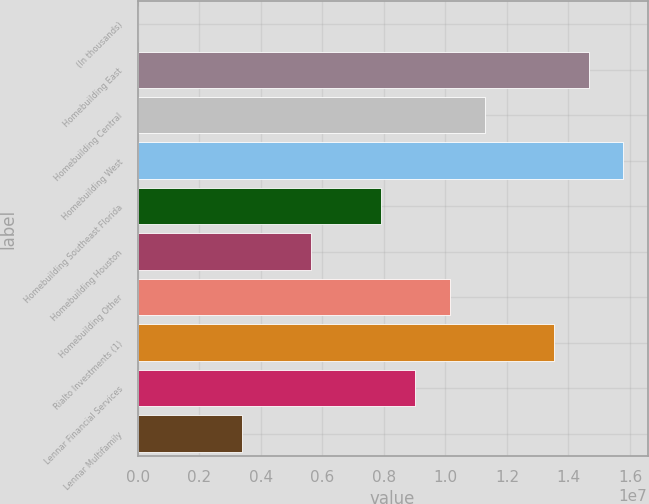Convert chart to OTSL. <chart><loc_0><loc_0><loc_500><loc_500><bar_chart><fcel>(In thousands)<fcel>Homebuilding East<fcel>Homebuilding Central<fcel>Homebuilding West<fcel>Homebuilding Southeast Florida<fcel>Homebuilding Houston<fcel>Homebuilding Other<fcel>Rialto Investments (1)<fcel>Lennar Financial Services<fcel>Lennar Multifamily<nl><fcel>2013<fcel>1.46546e+07<fcel>1.12732e+07<fcel>1.57817e+07<fcel>7.89188e+06<fcel>5.63763e+06<fcel>1.01461e+07<fcel>1.35275e+07<fcel>9.019e+06<fcel>3.38338e+06<nl></chart> 